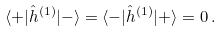<formula> <loc_0><loc_0><loc_500><loc_500>\langle + | { \hat { h } } ^ { ( 1 ) } | - \rangle = \langle - | { \hat { h } } ^ { ( 1 ) } | + \rangle = 0 \, .</formula> 